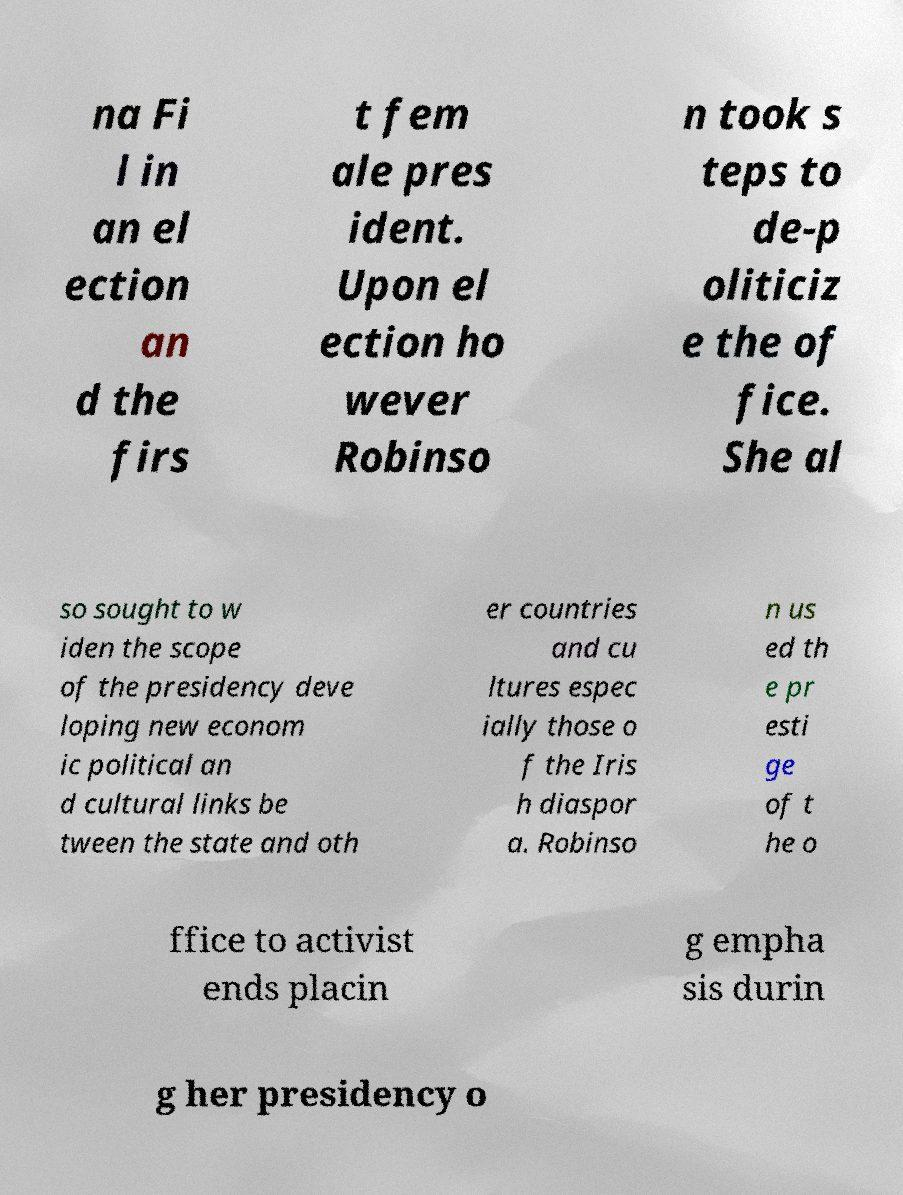What messages or text are displayed in this image? I need them in a readable, typed format. na Fi l in an el ection an d the firs t fem ale pres ident. Upon el ection ho wever Robinso n took s teps to de-p oliticiz e the of fice. She al so sought to w iden the scope of the presidency deve loping new econom ic political an d cultural links be tween the state and oth er countries and cu ltures espec ially those o f the Iris h diaspor a. Robinso n us ed th e pr esti ge of t he o ffice to activist ends placin g empha sis durin g her presidency o 